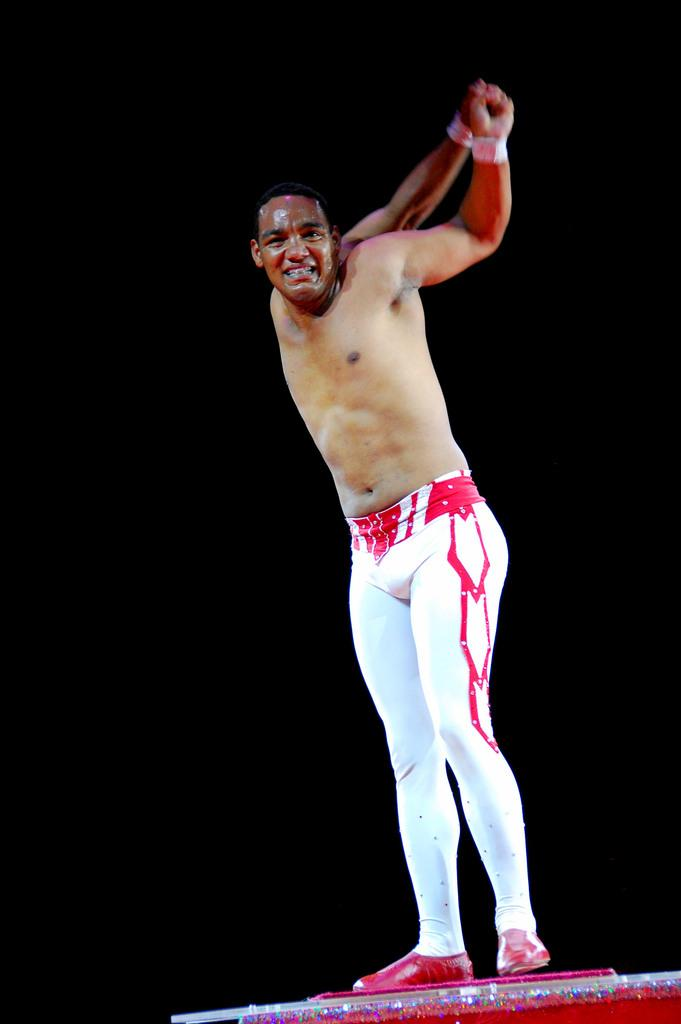What is the main subject of the image? There is a man in the image. What is the man wearing on his lower body? The man is wearing white sweatpants. Can you describe the setting or location of the image? The man is not standing on a stage. What type of dock can be seen in the image? There is no dock present in the image. What country is the man from in the image? The country of origin of the man cannot be determined from the image. 